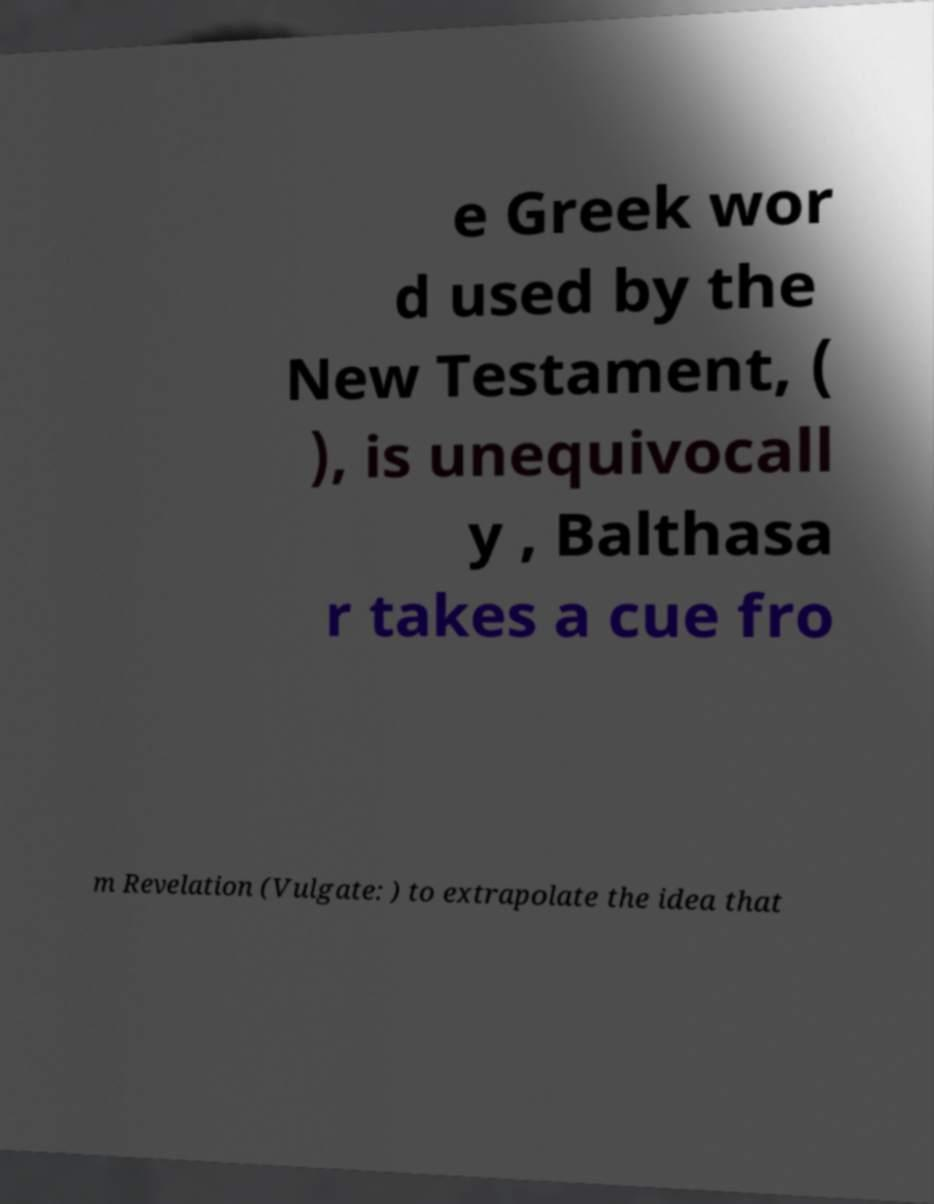Can you read and provide the text displayed in the image?This photo seems to have some interesting text. Can you extract and type it out for me? e Greek wor d used by the New Testament, ( ), is unequivocall y , Balthasa r takes a cue fro m Revelation (Vulgate: ) to extrapolate the idea that 